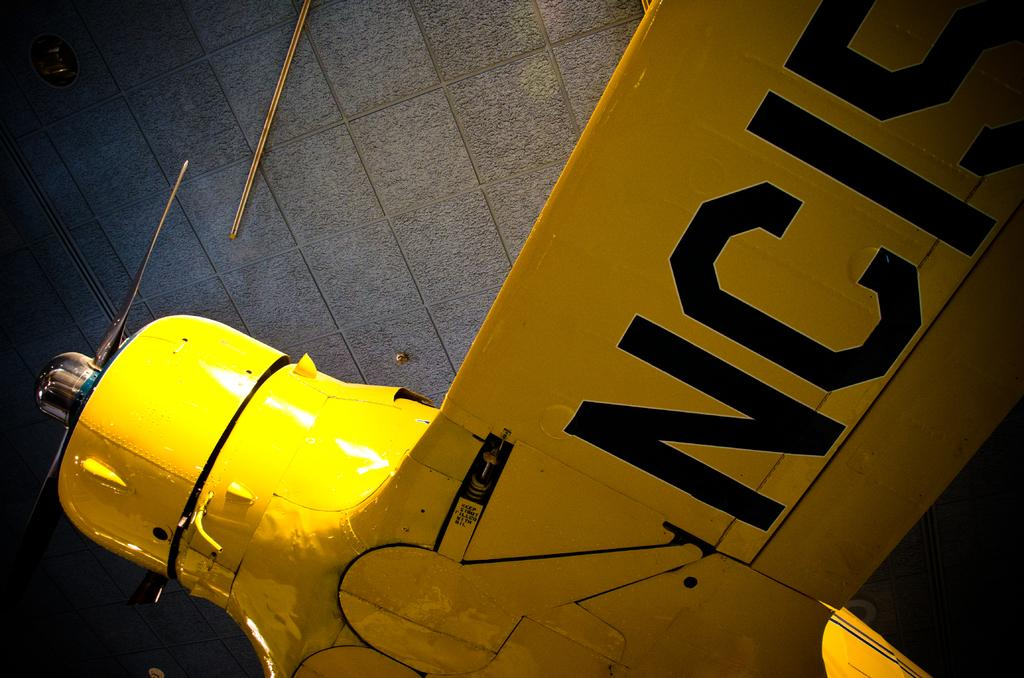Provide a one-sentence caption for the provided image. A yellow hydrant next to an NCIS sign. 